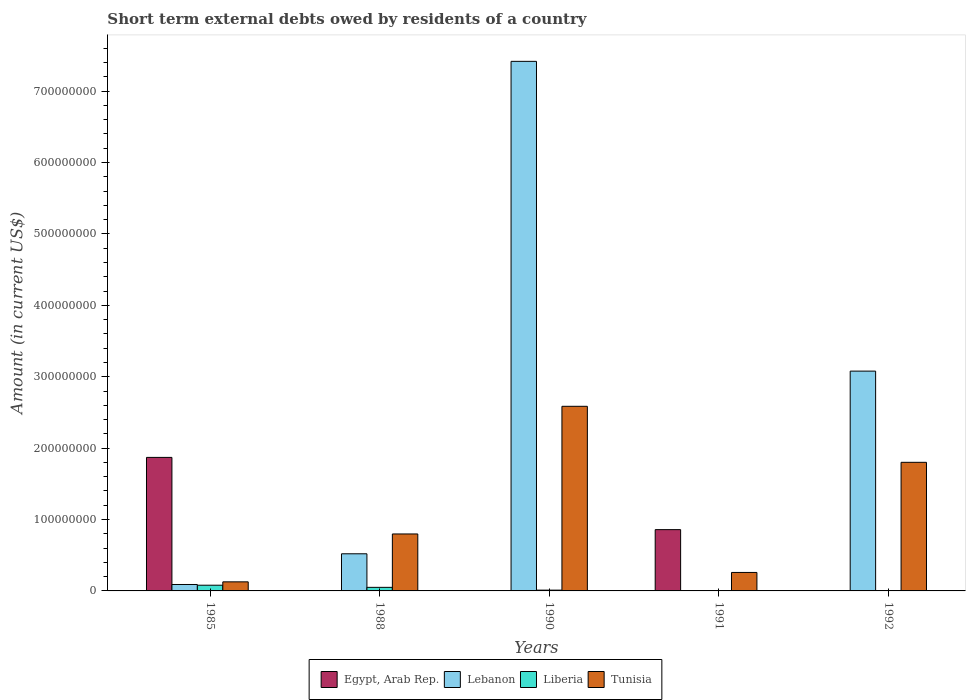Are the number of bars per tick equal to the number of legend labels?
Provide a short and direct response. No. Are the number of bars on each tick of the X-axis equal?
Your answer should be compact. No. How many bars are there on the 4th tick from the left?
Offer a terse response. 2. What is the label of the 1st group of bars from the left?
Provide a succinct answer. 1985. Across all years, what is the maximum amount of short-term external debts owed by residents in Lebanon?
Offer a terse response. 7.42e+08. Across all years, what is the minimum amount of short-term external debts owed by residents in Tunisia?
Your response must be concise. 1.27e+07. What is the total amount of short-term external debts owed by residents in Tunisia in the graph?
Provide a succinct answer. 5.57e+08. What is the difference between the amount of short-term external debts owed by residents in Egypt, Arab Rep. in 1985 and that in 1991?
Keep it short and to the point. 1.01e+08. What is the difference between the amount of short-term external debts owed by residents in Lebanon in 1988 and the amount of short-term external debts owed by residents in Liberia in 1985?
Make the answer very short. 4.40e+07. What is the average amount of short-term external debts owed by residents in Tunisia per year?
Give a very brief answer. 1.11e+08. In the year 1990, what is the difference between the amount of short-term external debts owed by residents in Liberia and amount of short-term external debts owed by residents in Tunisia?
Your answer should be very brief. -2.57e+08. What is the ratio of the amount of short-term external debts owed by residents in Lebanon in 1985 to that in 1988?
Your answer should be compact. 0.17. Is the amount of short-term external debts owed by residents in Egypt, Arab Rep. in 1985 less than that in 1991?
Your response must be concise. No. What is the difference between the highest and the second highest amount of short-term external debts owed by residents in Lebanon?
Your response must be concise. 4.34e+08. What is the difference between the highest and the lowest amount of short-term external debts owed by residents in Liberia?
Your answer should be compact. 8.00e+06. In how many years, is the amount of short-term external debts owed by residents in Tunisia greater than the average amount of short-term external debts owed by residents in Tunisia taken over all years?
Your answer should be very brief. 2. Is it the case that in every year, the sum of the amount of short-term external debts owed by residents in Egypt, Arab Rep. and amount of short-term external debts owed by residents in Tunisia is greater than the sum of amount of short-term external debts owed by residents in Lebanon and amount of short-term external debts owed by residents in Liberia?
Ensure brevity in your answer.  No. How many bars are there?
Offer a very short reply. 14. Are all the bars in the graph horizontal?
Provide a succinct answer. No. Does the graph contain any zero values?
Offer a terse response. Yes. Does the graph contain grids?
Your answer should be compact. No. Where does the legend appear in the graph?
Keep it short and to the point. Bottom center. How are the legend labels stacked?
Give a very brief answer. Horizontal. What is the title of the graph?
Provide a succinct answer. Short term external debts owed by residents of a country. Does "Mauritania" appear as one of the legend labels in the graph?
Your response must be concise. No. What is the label or title of the X-axis?
Offer a very short reply. Years. What is the label or title of the Y-axis?
Your answer should be very brief. Amount (in current US$). What is the Amount (in current US$) in Egypt, Arab Rep. in 1985?
Ensure brevity in your answer.  1.87e+08. What is the Amount (in current US$) of Lebanon in 1985?
Give a very brief answer. 9.00e+06. What is the Amount (in current US$) in Liberia in 1985?
Provide a succinct answer. 8.00e+06. What is the Amount (in current US$) in Tunisia in 1985?
Your answer should be very brief. 1.27e+07. What is the Amount (in current US$) in Lebanon in 1988?
Provide a succinct answer. 5.20e+07. What is the Amount (in current US$) of Tunisia in 1988?
Make the answer very short. 7.98e+07. What is the Amount (in current US$) in Lebanon in 1990?
Your answer should be compact. 7.42e+08. What is the Amount (in current US$) in Liberia in 1990?
Make the answer very short. 1.10e+06. What is the Amount (in current US$) in Tunisia in 1990?
Your answer should be compact. 2.59e+08. What is the Amount (in current US$) in Egypt, Arab Rep. in 1991?
Make the answer very short. 8.58e+07. What is the Amount (in current US$) in Lebanon in 1991?
Provide a short and direct response. 0. What is the Amount (in current US$) in Tunisia in 1991?
Offer a terse response. 2.59e+07. What is the Amount (in current US$) in Egypt, Arab Rep. in 1992?
Offer a very short reply. 0. What is the Amount (in current US$) of Lebanon in 1992?
Ensure brevity in your answer.  3.08e+08. What is the Amount (in current US$) in Liberia in 1992?
Offer a terse response. 0. What is the Amount (in current US$) of Tunisia in 1992?
Offer a terse response. 1.80e+08. Across all years, what is the maximum Amount (in current US$) in Egypt, Arab Rep.?
Offer a terse response. 1.87e+08. Across all years, what is the maximum Amount (in current US$) of Lebanon?
Offer a terse response. 7.42e+08. Across all years, what is the maximum Amount (in current US$) in Liberia?
Give a very brief answer. 8.00e+06. Across all years, what is the maximum Amount (in current US$) in Tunisia?
Your answer should be compact. 2.59e+08. Across all years, what is the minimum Amount (in current US$) in Egypt, Arab Rep.?
Your answer should be very brief. 0. Across all years, what is the minimum Amount (in current US$) of Liberia?
Your response must be concise. 0. Across all years, what is the minimum Amount (in current US$) in Tunisia?
Provide a short and direct response. 1.27e+07. What is the total Amount (in current US$) in Egypt, Arab Rep. in the graph?
Your response must be concise. 2.73e+08. What is the total Amount (in current US$) in Lebanon in the graph?
Give a very brief answer. 1.11e+09. What is the total Amount (in current US$) in Liberia in the graph?
Provide a succinct answer. 1.41e+07. What is the total Amount (in current US$) of Tunisia in the graph?
Keep it short and to the point. 5.57e+08. What is the difference between the Amount (in current US$) of Lebanon in 1985 and that in 1988?
Ensure brevity in your answer.  -4.30e+07. What is the difference between the Amount (in current US$) of Tunisia in 1985 and that in 1988?
Your response must be concise. -6.71e+07. What is the difference between the Amount (in current US$) in Lebanon in 1985 and that in 1990?
Offer a terse response. -7.33e+08. What is the difference between the Amount (in current US$) of Liberia in 1985 and that in 1990?
Give a very brief answer. 6.90e+06. What is the difference between the Amount (in current US$) in Tunisia in 1985 and that in 1990?
Your answer should be very brief. -2.46e+08. What is the difference between the Amount (in current US$) of Egypt, Arab Rep. in 1985 and that in 1991?
Your answer should be compact. 1.01e+08. What is the difference between the Amount (in current US$) of Tunisia in 1985 and that in 1991?
Ensure brevity in your answer.  -1.32e+07. What is the difference between the Amount (in current US$) in Lebanon in 1985 and that in 1992?
Give a very brief answer. -2.99e+08. What is the difference between the Amount (in current US$) of Tunisia in 1985 and that in 1992?
Keep it short and to the point. -1.67e+08. What is the difference between the Amount (in current US$) in Lebanon in 1988 and that in 1990?
Your answer should be compact. -6.90e+08. What is the difference between the Amount (in current US$) in Liberia in 1988 and that in 1990?
Provide a succinct answer. 3.90e+06. What is the difference between the Amount (in current US$) of Tunisia in 1988 and that in 1990?
Your answer should be very brief. -1.79e+08. What is the difference between the Amount (in current US$) of Tunisia in 1988 and that in 1991?
Give a very brief answer. 5.39e+07. What is the difference between the Amount (in current US$) of Lebanon in 1988 and that in 1992?
Offer a very short reply. -2.56e+08. What is the difference between the Amount (in current US$) in Tunisia in 1988 and that in 1992?
Your answer should be very brief. -1.00e+08. What is the difference between the Amount (in current US$) in Tunisia in 1990 and that in 1991?
Offer a terse response. 2.33e+08. What is the difference between the Amount (in current US$) of Lebanon in 1990 and that in 1992?
Give a very brief answer. 4.34e+08. What is the difference between the Amount (in current US$) of Tunisia in 1990 and that in 1992?
Provide a succinct answer. 7.84e+07. What is the difference between the Amount (in current US$) of Tunisia in 1991 and that in 1992?
Offer a very short reply. -1.54e+08. What is the difference between the Amount (in current US$) of Egypt, Arab Rep. in 1985 and the Amount (in current US$) of Lebanon in 1988?
Provide a short and direct response. 1.35e+08. What is the difference between the Amount (in current US$) in Egypt, Arab Rep. in 1985 and the Amount (in current US$) in Liberia in 1988?
Offer a terse response. 1.82e+08. What is the difference between the Amount (in current US$) in Egypt, Arab Rep. in 1985 and the Amount (in current US$) in Tunisia in 1988?
Provide a succinct answer. 1.07e+08. What is the difference between the Amount (in current US$) of Lebanon in 1985 and the Amount (in current US$) of Liberia in 1988?
Ensure brevity in your answer.  4.00e+06. What is the difference between the Amount (in current US$) in Lebanon in 1985 and the Amount (in current US$) in Tunisia in 1988?
Provide a short and direct response. -7.08e+07. What is the difference between the Amount (in current US$) in Liberia in 1985 and the Amount (in current US$) in Tunisia in 1988?
Give a very brief answer. -7.18e+07. What is the difference between the Amount (in current US$) of Egypt, Arab Rep. in 1985 and the Amount (in current US$) of Lebanon in 1990?
Offer a terse response. -5.55e+08. What is the difference between the Amount (in current US$) of Egypt, Arab Rep. in 1985 and the Amount (in current US$) of Liberia in 1990?
Offer a very short reply. 1.86e+08. What is the difference between the Amount (in current US$) in Egypt, Arab Rep. in 1985 and the Amount (in current US$) in Tunisia in 1990?
Keep it short and to the point. -7.16e+07. What is the difference between the Amount (in current US$) in Lebanon in 1985 and the Amount (in current US$) in Liberia in 1990?
Offer a terse response. 7.90e+06. What is the difference between the Amount (in current US$) of Lebanon in 1985 and the Amount (in current US$) of Tunisia in 1990?
Provide a short and direct response. -2.50e+08. What is the difference between the Amount (in current US$) of Liberia in 1985 and the Amount (in current US$) of Tunisia in 1990?
Give a very brief answer. -2.51e+08. What is the difference between the Amount (in current US$) of Egypt, Arab Rep. in 1985 and the Amount (in current US$) of Tunisia in 1991?
Provide a short and direct response. 1.61e+08. What is the difference between the Amount (in current US$) in Lebanon in 1985 and the Amount (in current US$) in Tunisia in 1991?
Your answer should be compact. -1.69e+07. What is the difference between the Amount (in current US$) of Liberia in 1985 and the Amount (in current US$) of Tunisia in 1991?
Make the answer very short. -1.79e+07. What is the difference between the Amount (in current US$) in Egypt, Arab Rep. in 1985 and the Amount (in current US$) in Lebanon in 1992?
Your answer should be very brief. -1.21e+08. What is the difference between the Amount (in current US$) of Egypt, Arab Rep. in 1985 and the Amount (in current US$) of Tunisia in 1992?
Your answer should be very brief. 6.89e+06. What is the difference between the Amount (in current US$) of Lebanon in 1985 and the Amount (in current US$) of Tunisia in 1992?
Your answer should be compact. -1.71e+08. What is the difference between the Amount (in current US$) of Liberia in 1985 and the Amount (in current US$) of Tunisia in 1992?
Provide a short and direct response. -1.72e+08. What is the difference between the Amount (in current US$) of Lebanon in 1988 and the Amount (in current US$) of Liberia in 1990?
Provide a short and direct response. 5.09e+07. What is the difference between the Amount (in current US$) of Lebanon in 1988 and the Amount (in current US$) of Tunisia in 1990?
Your answer should be compact. -2.07e+08. What is the difference between the Amount (in current US$) in Liberia in 1988 and the Amount (in current US$) in Tunisia in 1990?
Ensure brevity in your answer.  -2.54e+08. What is the difference between the Amount (in current US$) of Lebanon in 1988 and the Amount (in current US$) of Tunisia in 1991?
Ensure brevity in your answer.  2.61e+07. What is the difference between the Amount (in current US$) of Liberia in 1988 and the Amount (in current US$) of Tunisia in 1991?
Your response must be concise. -2.09e+07. What is the difference between the Amount (in current US$) of Lebanon in 1988 and the Amount (in current US$) of Tunisia in 1992?
Give a very brief answer. -1.28e+08. What is the difference between the Amount (in current US$) of Liberia in 1988 and the Amount (in current US$) of Tunisia in 1992?
Your response must be concise. -1.75e+08. What is the difference between the Amount (in current US$) in Lebanon in 1990 and the Amount (in current US$) in Tunisia in 1991?
Your answer should be very brief. 7.16e+08. What is the difference between the Amount (in current US$) in Liberia in 1990 and the Amount (in current US$) in Tunisia in 1991?
Your answer should be very brief. -2.48e+07. What is the difference between the Amount (in current US$) in Lebanon in 1990 and the Amount (in current US$) in Tunisia in 1992?
Provide a succinct answer. 5.62e+08. What is the difference between the Amount (in current US$) of Liberia in 1990 and the Amount (in current US$) of Tunisia in 1992?
Keep it short and to the point. -1.79e+08. What is the difference between the Amount (in current US$) in Egypt, Arab Rep. in 1991 and the Amount (in current US$) in Lebanon in 1992?
Offer a terse response. -2.22e+08. What is the difference between the Amount (in current US$) in Egypt, Arab Rep. in 1991 and the Amount (in current US$) in Tunisia in 1992?
Offer a terse response. -9.43e+07. What is the average Amount (in current US$) of Egypt, Arab Rep. per year?
Your answer should be compact. 5.46e+07. What is the average Amount (in current US$) of Lebanon per year?
Your answer should be compact. 2.22e+08. What is the average Amount (in current US$) of Liberia per year?
Your response must be concise. 2.82e+06. What is the average Amount (in current US$) in Tunisia per year?
Ensure brevity in your answer.  1.11e+08. In the year 1985, what is the difference between the Amount (in current US$) in Egypt, Arab Rep. and Amount (in current US$) in Lebanon?
Offer a terse response. 1.78e+08. In the year 1985, what is the difference between the Amount (in current US$) in Egypt, Arab Rep. and Amount (in current US$) in Liberia?
Give a very brief answer. 1.79e+08. In the year 1985, what is the difference between the Amount (in current US$) of Egypt, Arab Rep. and Amount (in current US$) of Tunisia?
Your response must be concise. 1.74e+08. In the year 1985, what is the difference between the Amount (in current US$) of Lebanon and Amount (in current US$) of Tunisia?
Offer a terse response. -3.70e+06. In the year 1985, what is the difference between the Amount (in current US$) in Liberia and Amount (in current US$) in Tunisia?
Your answer should be very brief. -4.70e+06. In the year 1988, what is the difference between the Amount (in current US$) of Lebanon and Amount (in current US$) of Liberia?
Offer a very short reply. 4.70e+07. In the year 1988, what is the difference between the Amount (in current US$) in Lebanon and Amount (in current US$) in Tunisia?
Give a very brief answer. -2.78e+07. In the year 1988, what is the difference between the Amount (in current US$) in Liberia and Amount (in current US$) in Tunisia?
Provide a short and direct response. -7.48e+07. In the year 1990, what is the difference between the Amount (in current US$) of Lebanon and Amount (in current US$) of Liberia?
Keep it short and to the point. 7.41e+08. In the year 1990, what is the difference between the Amount (in current US$) of Lebanon and Amount (in current US$) of Tunisia?
Your answer should be compact. 4.83e+08. In the year 1990, what is the difference between the Amount (in current US$) of Liberia and Amount (in current US$) of Tunisia?
Keep it short and to the point. -2.57e+08. In the year 1991, what is the difference between the Amount (in current US$) in Egypt, Arab Rep. and Amount (in current US$) in Tunisia?
Your response must be concise. 6.00e+07. In the year 1992, what is the difference between the Amount (in current US$) in Lebanon and Amount (in current US$) in Tunisia?
Make the answer very short. 1.28e+08. What is the ratio of the Amount (in current US$) in Lebanon in 1985 to that in 1988?
Your answer should be very brief. 0.17. What is the ratio of the Amount (in current US$) of Liberia in 1985 to that in 1988?
Your answer should be compact. 1.6. What is the ratio of the Amount (in current US$) in Tunisia in 1985 to that in 1988?
Keep it short and to the point. 0.16. What is the ratio of the Amount (in current US$) of Lebanon in 1985 to that in 1990?
Your response must be concise. 0.01. What is the ratio of the Amount (in current US$) in Liberia in 1985 to that in 1990?
Your response must be concise. 7.27. What is the ratio of the Amount (in current US$) of Tunisia in 1985 to that in 1990?
Provide a short and direct response. 0.05. What is the ratio of the Amount (in current US$) in Egypt, Arab Rep. in 1985 to that in 1991?
Your response must be concise. 2.18. What is the ratio of the Amount (in current US$) in Tunisia in 1985 to that in 1991?
Keep it short and to the point. 0.49. What is the ratio of the Amount (in current US$) of Lebanon in 1985 to that in 1992?
Give a very brief answer. 0.03. What is the ratio of the Amount (in current US$) of Tunisia in 1985 to that in 1992?
Make the answer very short. 0.07. What is the ratio of the Amount (in current US$) in Lebanon in 1988 to that in 1990?
Give a very brief answer. 0.07. What is the ratio of the Amount (in current US$) in Liberia in 1988 to that in 1990?
Provide a succinct answer. 4.55. What is the ratio of the Amount (in current US$) in Tunisia in 1988 to that in 1990?
Keep it short and to the point. 0.31. What is the ratio of the Amount (in current US$) in Tunisia in 1988 to that in 1991?
Offer a terse response. 3.08. What is the ratio of the Amount (in current US$) of Lebanon in 1988 to that in 1992?
Your response must be concise. 0.17. What is the ratio of the Amount (in current US$) of Tunisia in 1988 to that in 1992?
Your response must be concise. 0.44. What is the ratio of the Amount (in current US$) of Tunisia in 1990 to that in 1991?
Provide a short and direct response. 9.99. What is the ratio of the Amount (in current US$) of Lebanon in 1990 to that in 1992?
Offer a very short reply. 2.41. What is the ratio of the Amount (in current US$) in Tunisia in 1990 to that in 1992?
Your answer should be very brief. 1.44. What is the ratio of the Amount (in current US$) in Tunisia in 1991 to that in 1992?
Your answer should be compact. 0.14. What is the difference between the highest and the second highest Amount (in current US$) of Lebanon?
Give a very brief answer. 4.34e+08. What is the difference between the highest and the second highest Amount (in current US$) of Liberia?
Ensure brevity in your answer.  3.00e+06. What is the difference between the highest and the second highest Amount (in current US$) of Tunisia?
Keep it short and to the point. 7.84e+07. What is the difference between the highest and the lowest Amount (in current US$) in Egypt, Arab Rep.?
Provide a succinct answer. 1.87e+08. What is the difference between the highest and the lowest Amount (in current US$) of Lebanon?
Your response must be concise. 7.42e+08. What is the difference between the highest and the lowest Amount (in current US$) in Tunisia?
Offer a very short reply. 2.46e+08. 